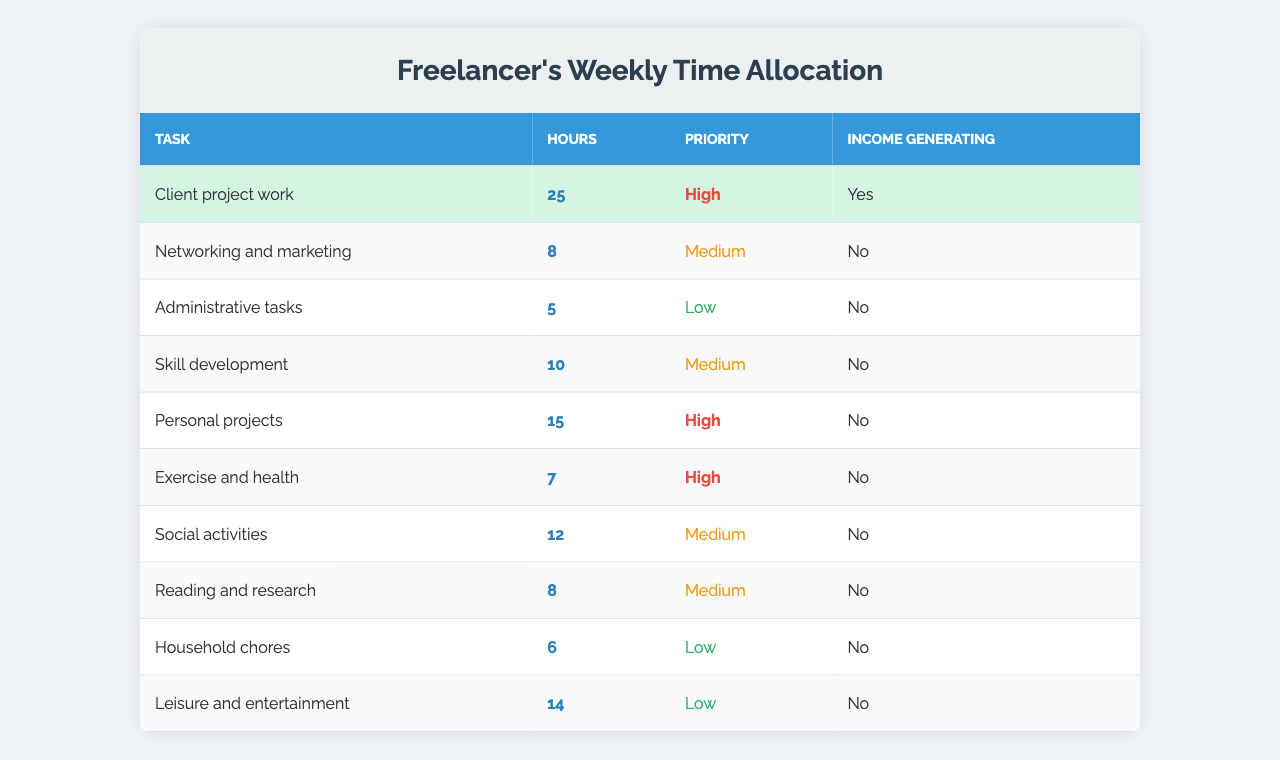What task has the highest number of hours allocated? By examining the "Hours" column, "Client project work" has the highest allocation with 25 hours.
Answer: Client project work How many total hours are spent on income-generating tasks? The only income-generating task is "Client project work," which has 25 hours allocated. Thus, the total is 25 hours.
Answer: 25 What is the total time allocation for personal projects and leisure activities combined? "Personal projects" has 15 hours and "Leisure and entertainment" has 14 hours. Adding these gives 15 + 14 = 29 hours.
Answer: 29 Which task has the lowest priority but also requires the least hours? The task "Administrative tasks" has a low priority and only requires 5 hours, making it the least in both categories.
Answer: Administrative tasks Is "Skill development" an income-generating task? According to the table, "Skill development" is listed as not income-generating.
Answer: No What percentage of the total hours is devoted to "Networking and marketing"? The total hours across all tasks is 25 + 8 + 5 + 10 + 15 + 7 + 12 + 8 + 6 + 14 = 110 hours. "Networking and marketing" has 8 hours. The percentage is (8/110) * 100 ≈ 7.27%.
Answer: Approximately 7.27% How many more hours are dedicated to exercise and health compared to administrative tasks? "Exercise and health" has 7 hours, and "Administrative tasks" has 5 hours. The difference is 7 - 5 = 2 hours more.
Answer: 2 If a freelancer dedicates all their networking and marketing time to client acquisition, how would it impact their overall hourly commitment? Currently, 8 hours are devoted to networking. Adding this to the existing 25 hours of client project work gives a new total of 25 + 8 = 33 hours devoted to work-related tasks.
Answer: 33 What is the average number of hours spent per task across all tasks listed? There are 10 tasks with a total of 110 hours. The average is 110 / 10 = 11 hours per task.
Answer: 11 Identify the two highest-priority tasks and state their total hours combined. The two highest-priority tasks are "Client project work" (25 hours) and "Personal projects" (15 hours). The combined total is 25 + 15 = 40 hours.
Answer: 40 